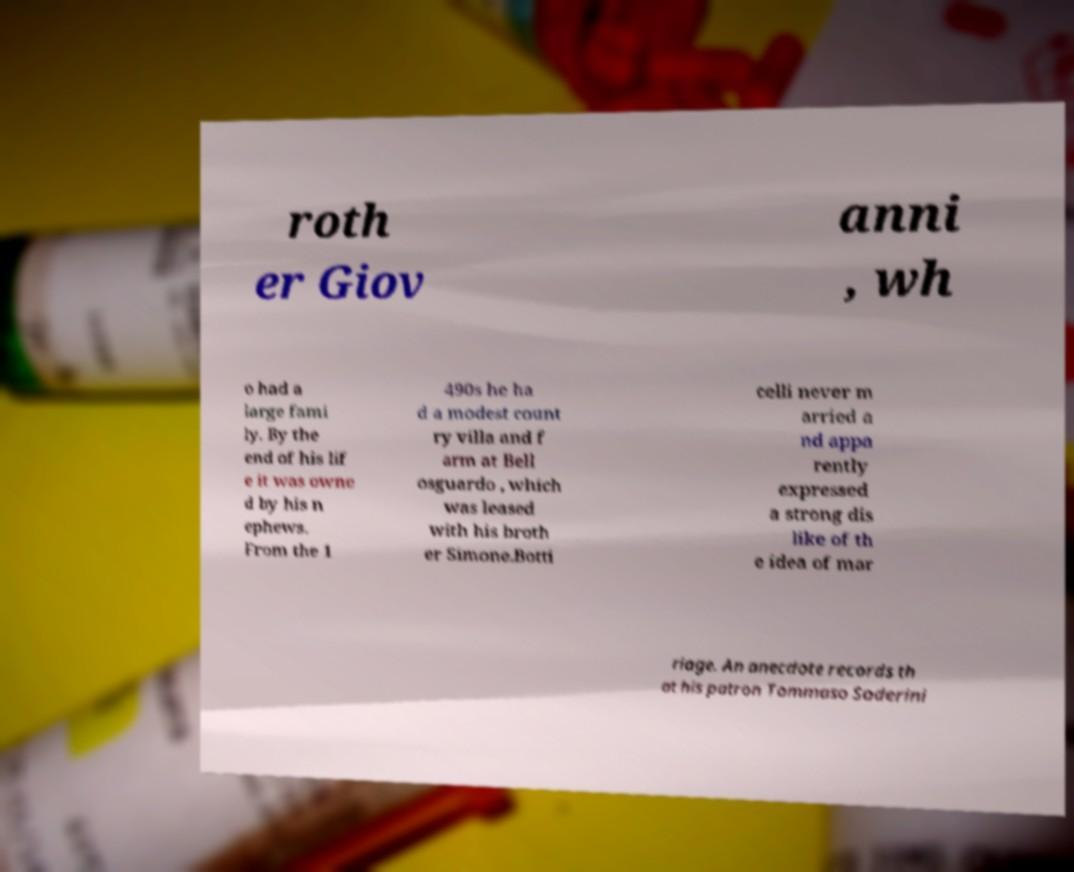Could you assist in decoding the text presented in this image and type it out clearly? roth er Giov anni , wh o had a large fami ly. By the end of his lif e it was owne d by his n ephews. From the 1 490s he ha d a modest count ry villa and f arm at Bell osguardo , which was leased with his broth er Simone.Botti celli never m arried a nd appa rently expressed a strong dis like of th e idea of mar riage. An anecdote records th at his patron Tommaso Soderini 